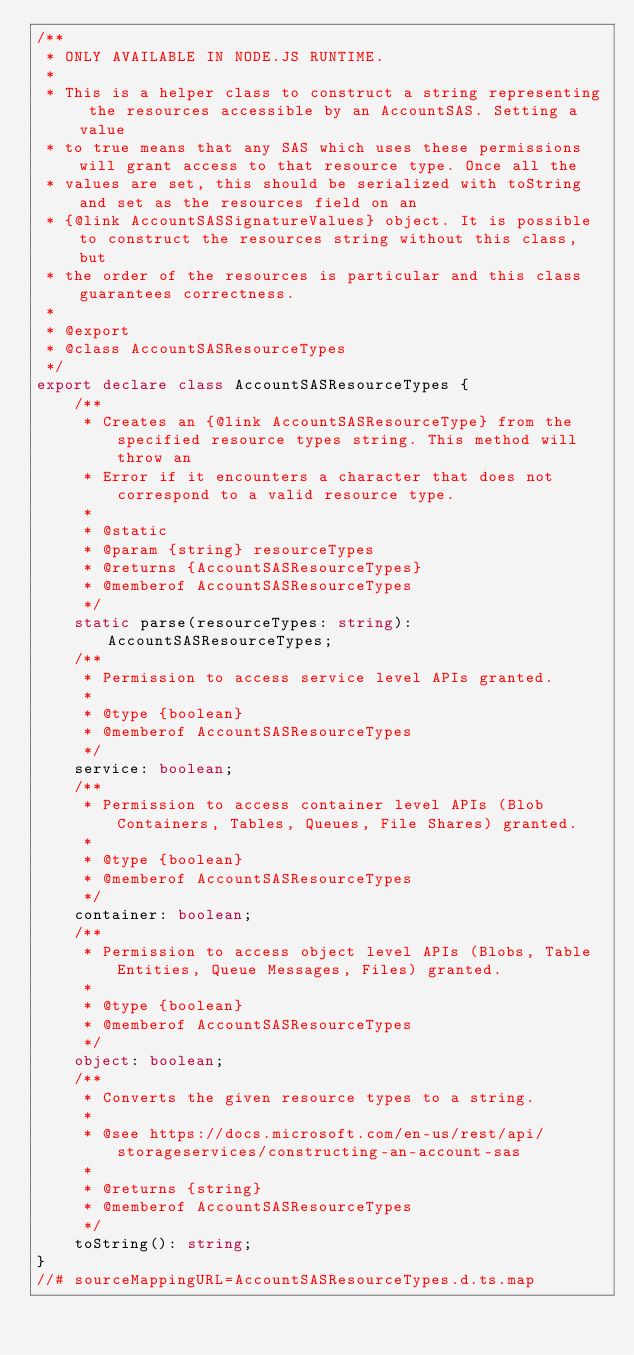Convert code to text. <code><loc_0><loc_0><loc_500><loc_500><_TypeScript_>/**
 * ONLY AVAILABLE IN NODE.JS RUNTIME.
 *
 * This is a helper class to construct a string representing the resources accessible by an AccountSAS. Setting a value
 * to true means that any SAS which uses these permissions will grant access to that resource type. Once all the
 * values are set, this should be serialized with toString and set as the resources field on an
 * {@link AccountSASSignatureValues} object. It is possible to construct the resources string without this class, but
 * the order of the resources is particular and this class guarantees correctness.
 *
 * @export
 * @class AccountSASResourceTypes
 */
export declare class AccountSASResourceTypes {
    /**
     * Creates an {@link AccountSASResourceType} from the specified resource types string. This method will throw an
     * Error if it encounters a character that does not correspond to a valid resource type.
     *
     * @static
     * @param {string} resourceTypes
     * @returns {AccountSASResourceTypes}
     * @memberof AccountSASResourceTypes
     */
    static parse(resourceTypes: string): AccountSASResourceTypes;
    /**
     * Permission to access service level APIs granted.
     *
     * @type {boolean}
     * @memberof AccountSASResourceTypes
     */
    service: boolean;
    /**
     * Permission to access container level APIs (Blob Containers, Tables, Queues, File Shares) granted.
     *
     * @type {boolean}
     * @memberof AccountSASResourceTypes
     */
    container: boolean;
    /**
     * Permission to access object level APIs (Blobs, Table Entities, Queue Messages, Files) granted.
     *
     * @type {boolean}
     * @memberof AccountSASResourceTypes
     */
    object: boolean;
    /**
     * Converts the given resource types to a string.
     *
     * @see https://docs.microsoft.com/en-us/rest/api/storageservices/constructing-an-account-sas
     *
     * @returns {string}
     * @memberof AccountSASResourceTypes
     */
    toString(): string;
}
//# sourceMappingURL=AccountSASResourceTypes.d.ts.map</code> 